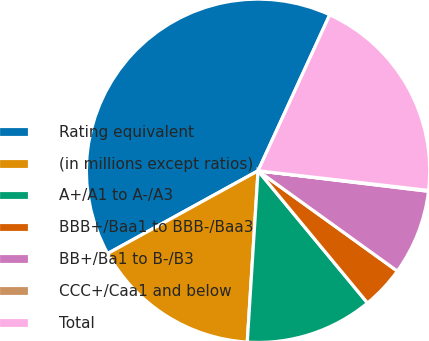Convert chart to OTSL. <chart><loc_0><loc_0><loc_500><loc_500><pie_chart><fcel>Rating equivalent<fcel>(in millions except ratios)<fcel>A+/A1 to A-/A3<fcel>BBB+/Baa1 to BBB-/Baa3<fcel>BB+/Ba1 to B-/B3<fcel>CCC+/Caa1 and below<fcel>Total<nl><fcel>39.86%<fcel>15.99%<fcel>12.01%<fcel>4.06%<fcel>8.03%<fcel>0.08%<fcel>19.97%<nl></chart> 